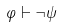<formula> <loc_0><loc_0><loc_500><loc_500>\varphi \vdash \neg \psi</formula> 